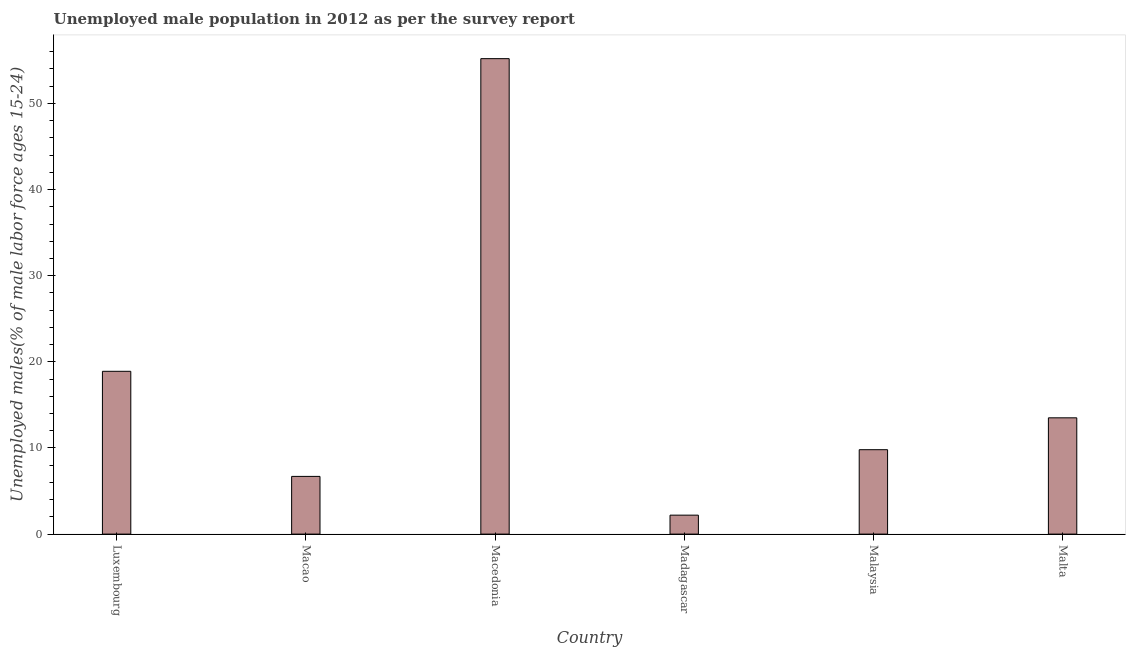Does the graph contain any zero values?
Make the answer very short. No. Does the graph contain grids?
Ensure brevity in your answer.  No. What is the title of the graph?
Provide a short and direct response. Unemployed male population in 2012 as per the survey report. What is the label or title of the X-axis?
Provide a succinct answer. Country. What is the label or title of the Y-axis?
Your response must be concise. Unemployed males(% of male labor force ages 15-24). What is the unemployed male youth in Macedonia?
Your response must be concise. 55.2. Across all countries, what is the maximum unemployed male youth?
Keep it short and to the point. 55.2. Across all countries, what is the minimum unemployed male youth?
Offer a very short reply. 2.2. In which country was the unemployed male youth maximum?
Give a very brief answer. Macedonia. In which country was the unemployed male youth minimum?
Keep it short and to the point. Madagascar. What is the sum of the unemployed male youth?
Your response must be concise. 106.3. What is the average unemployed male youth per country?
Offer a terse response. 17.72. What is the median unemployed male youth?
Offer a terse response. 11.65. What is the ratio of the unemployed male youth in Macao to that in Madagascar?
Offer a terse response. 3.04. Is the unemployed male youth in Malaysia less than that in Malta?
Ensure brevity in your answer.  Yes. What is the difference between the highest and the second highest unemployed male youth?
Your answer should be very brief. 36.3. What is the difference between the highest and the lowest unemployed male youth?
Make the answer very short. 53. In how many countries, is the unemployed male youth greater than the average unemployed male youth taken over all countries?
Provide a succinct answer. 2. How many bars are there?
Your answer should be compact. 6. Are all the bars in the graph horizontal?
Your response must be concise. No. What is the difference between two consecutive major ticks on the Y-axis?
Provide a succinct answer. 10. Are the values on the major ticks of Y-axis written in scientific E-notation?
Ensure brevity in your answer.  No. What is the Unemployed males(% of male labor force ages 15-24) of Luxembourg?
Make the answer very short. 18.9. What is the Unemployed males(% of male labor force ages 15-24) in Macao?
Ensure brevity in your answer.  6.7. What is the Unemployed males(% of male labor force ages 15-24) in Macedonia?
Your answer should be very brief. 55.2. What is the Unemployed males(% of male labor force ages 15-24) of Madagascar?
Offer a terse response. 2.2. What is the Unemployed males(% of male labor force ages 15-24) in Malaysia?
Keep it short and to the point. 9.8. What is the difference between the Unemployed males(% of male labor force ages 15-24) in Luxembourg and Macedonia?
Offer a very short reply. -36.3. What is the difference between the Unemployed males(% of male labor force ages 15-24) in Luxembourg and Malta?
Provide a short and direct response. 5.4. What is the difference between the Unemployed males(% of male labor force ages 15-24) in Macao and Macedonia?
Make the answer very short. -48.5. What is the difference between the Unemployed males(% of male labor force ages 15-24) in Macao and Madagascar?
Provide a short and direct response. 4.5. What is the difference between the Unemployed males(% of male labor force ages 15-24) in Macedonia and Malaysia?
Provide a short and direct response. 45.4. What is the difference between the Unemployed males(% of male labor force ages 15-24) in Macedonia and Malta?
Your answer should be very brief. 41.7. What is the difference between the Unemployed males(% of male labor force ages 15-24) in Madagascar and Malaysia?
Your answer should be compact. -7.6. What is the ratio of the Unemployed males(% of male labor force ages 15-24) in Luxembourg to that in Macao?
Ensure brevity in your answer.  2.82. What is the ratio of the Unemployed males(% of male labor force ages 15-24) in Luxembourg to that in Macedonia?
Your answer should be very brief. 0.34. What is the ratio of the Unemployed males(% of male labor force ages 15-24) in Luxembourg to that in Madagascar?
Ensure brevity in your answer.  8.59. What is the ratio of the Unemployed males(% of male labor force ages 15-24) in Luxembourg to that in Malaysia?
Your answer should be compact. 1.93. What is the ratio of the Unemployed males(% of male labor force ages 15-24) in Macao to that in Macedonia?
Make the answer very short. 0.12. What is the ratio of the Unemployed males(% of male labor force ages 15-24) in Macao to that in Madagascar?
Provide a short and direct response. 3.04. What is the ratio of the Unemployed males(% of male labor force ages 15-24) in Macao to that in Malaysia?
Your response must be concise. 0.68. What is the ratio of the Unemployed males(% of male labor force ages 15-24) in Macao to that in Malta?
Your response must be concise. 0.5. What is the ratio of the Unemployed males(% of male labor force ages 15-24) in Macedonia to that in Madagascar?
Ensure brevity in your answer.  25.09. What is the ratio of the Unemployed males(% of male labor force ages 15-24) in Macedonia to that in Malaysia?
Give a very brief answer. 5.63. What is the ratio of the Unemployed males(% of male labor force ages 15-24) in Macedonia to that in Malta?
Offer a terse response. 4.09. What is the ratio of the Unemployed males(% of male labor force ages 15-24) in Madagascar to that in Malaysia?
Ensure brevity in your answer.  0.22. What is the ratio of the Unemployed males(% of male labor force ages 15-24) in Madagascar to that in Malta?
Offer a very short reply. 0.16. What is the ratio of the Unemployed males(% of male labor force ages 15-24) in Malaysia to that in Malta?
Provide a short and direct response. 0.73. 